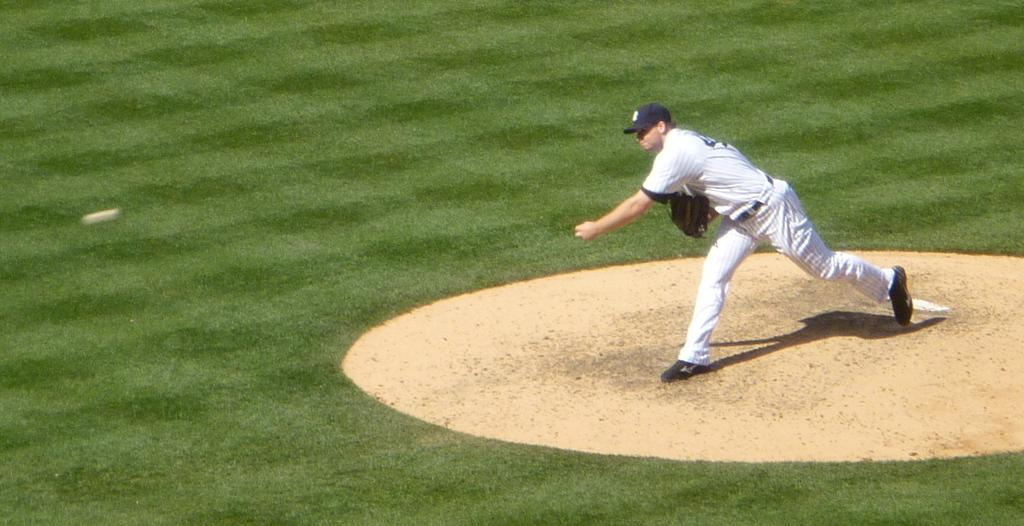What type of location is shown in the image? The image depicts a playground. What is the color of the grass in the playground? The grass in the playground is green. Can you describe the man in the image? The man is present in the image, wearing a white dress, and standing on the right side of the image. Which direction is the man facing in the image? The man is facing towards the left side of the image. What type of pets can be seen playing with the man in the image? There are no pets present in the image; it only shows a man standing on the playground. What kind of boot is the man wearing in the image? The man is not wearing a boot in the image; he is wearing a white dress. 